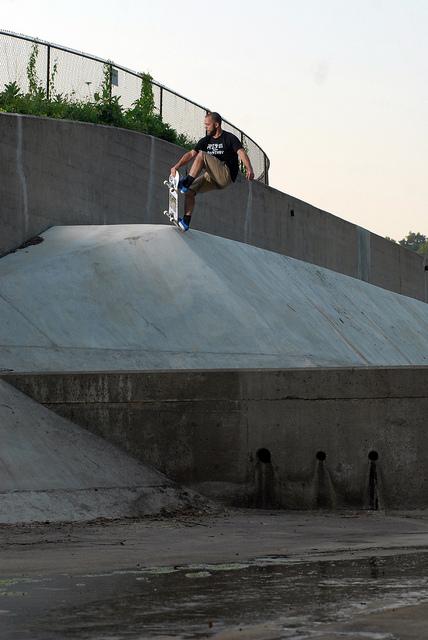Will the skater be injured if he falls from his position?
Write a very short answer. Yes. Is the guy an expert skater?
Keep it brief. Yes. What trick is the skater performing?
Answer briefly. Jump. 